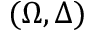<formula> <loc_0><loc_0><loc_500><loc_500>( \Omega , \Delta )</formula> 